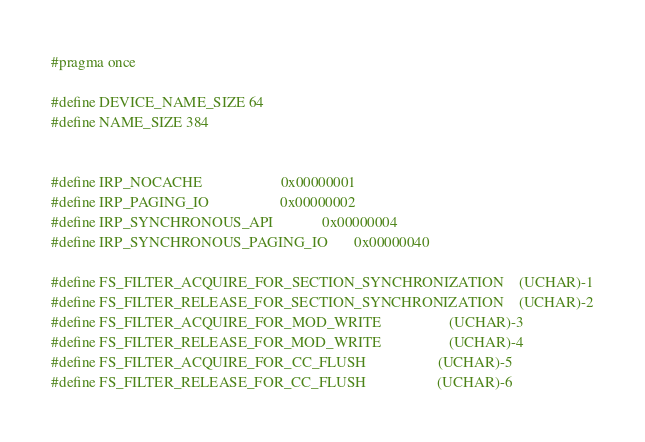Convert code to text. <code><loc_0><loc_0><loc_500><loc_500><_C_>#pragma once

#define DEVICE_NAME_SIZE 64
#define NAME_SIZE 384


#define IRP_NOCACHE                     0x00000001
#define IRP_PAGING_IO                   0x00000002
#define IRP_SYNCHRONOUS_API             0x00000004
#define IRP_SYNCHRONOUS_PAGING_IO       0x00000040

#define FS_FILTER_ACQUIRE_FOR_SECTION_SYNCHRONIZATION    (UCHAR)-1
#define FS_FILTER_RELEASE_FOR_SECTION_SYNCHRONIZATION    (UCHAR)-2
#define FS_FILTER_ACQUIRE_FOR_MOD_WRITE                  (UCHAR)-3
#define FS_FILTER_RELEASE_FOR_MOD_WRITE                  (UCHAR)-4
#define FS_FILTER_ACQUIRE_FOR_CC_FLUSH                   (UCHAR)-5
#define FS_FILTER_RELEASE_FOR_CC_FLUSH                   (UCHAR)-6

</code> 